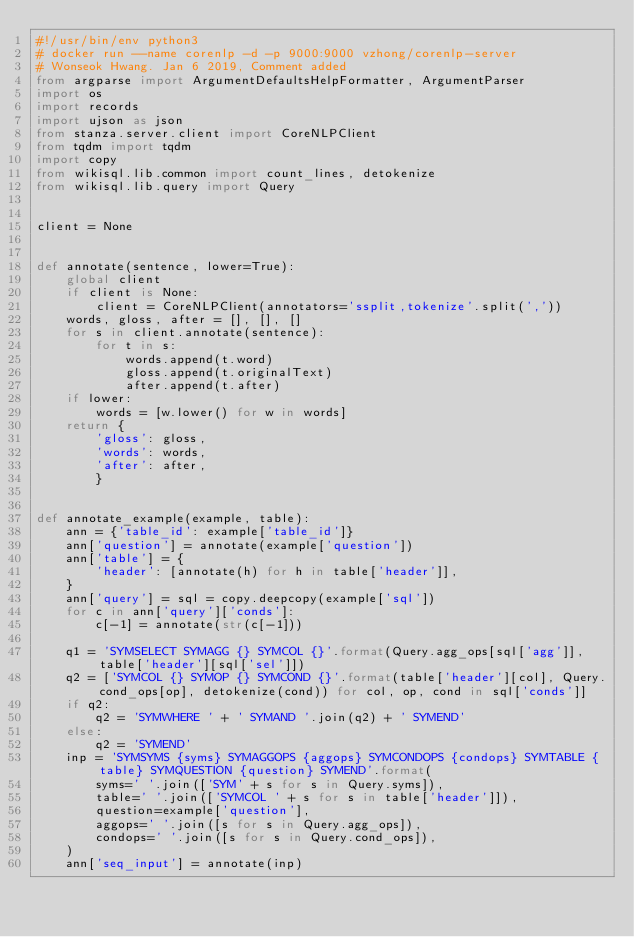<code> <loc_0><loc_0><loc_500><loc_500><_Python_>#!/usr/bin/env python3
# docker run --name corenlp -d -p 9000:9000 vzhong/corenlp-server
# Wonseok Hwang. Jan 6 2019, Comment added
from argparse import ArgumentDefaultsHelpFormatter, ArgumentParser
import os
import records
import ujson as json
from stanza.server.client import CoreNLPClient
from tqdm import tqdm
import copy
from wikisql.lib.common import count_lines, detokenize
from wikisql.lib.query import Query


client = None


def annotate(sentence, lower=True):
    global client
    if client is None:
        client = CoreNLPClient(annotators='ssplit,tokenize'.split(','))
    words, gloss, after = [], [], []
    for s in client.annotate(sentence):
        for t in s:
            words.append(t.word)
            gloss.append(t.originalText)
            after.append(t.after)
    if lower:
        words = [w.lower() for w in words]
    return {
        'gloss': gloss,
        'words': words,
        'after': after,
        }


def annotate_example(example, table):
    ann = {'table_id': example['table_id']}
    ann['question'] = annotate(example['question'])
    ann['table'] = {
        'header': [annotate(h) for h in table['header']],
    }
    ann['query'] = sql = copy.deepcopy(example['sql'])
    for c in ann['query']['conds']:
        c[-1] = annotate(str(c[-1]))

    q1 = 'SYMSELECT SYMAGG {} SYMCOL {}'.format(Query.agg_ops[sql['agg']], table['header'][sql['sel']])
    q2 = ['SYMCOL {} SYMOP {} SYMCOND {}'.format(table['header'][col], Query.cond_ops[op], detokenize(cond)) for col, op, cond in sql['conds']]
    if q2:
        q2 = 'SYMWHERE ' + ' SYMAND '.join(q2) + ' SYMEND'
    else:
        q2 = 'SYMEND'
    inp = 'SYMSYMS {syms} SYMAGGOPS {aggops} SYMCONDOPS {condops} SYMTABLE {table} SYMQUESTION {question} SYMEND'.format(
        syms=' '.join(['SYM' + s for s in Query.syms]),
        table=' '.join(['SYMCOL ' + s for s in table['header']]),
        question=example['question'],
        aggops=' '.join([s for s in Query.agg_ops]),
        condops=' '.join([s for s in Query.cond_ops]),
    )
    ann['seq_input'] = annotate(inp)</code> 